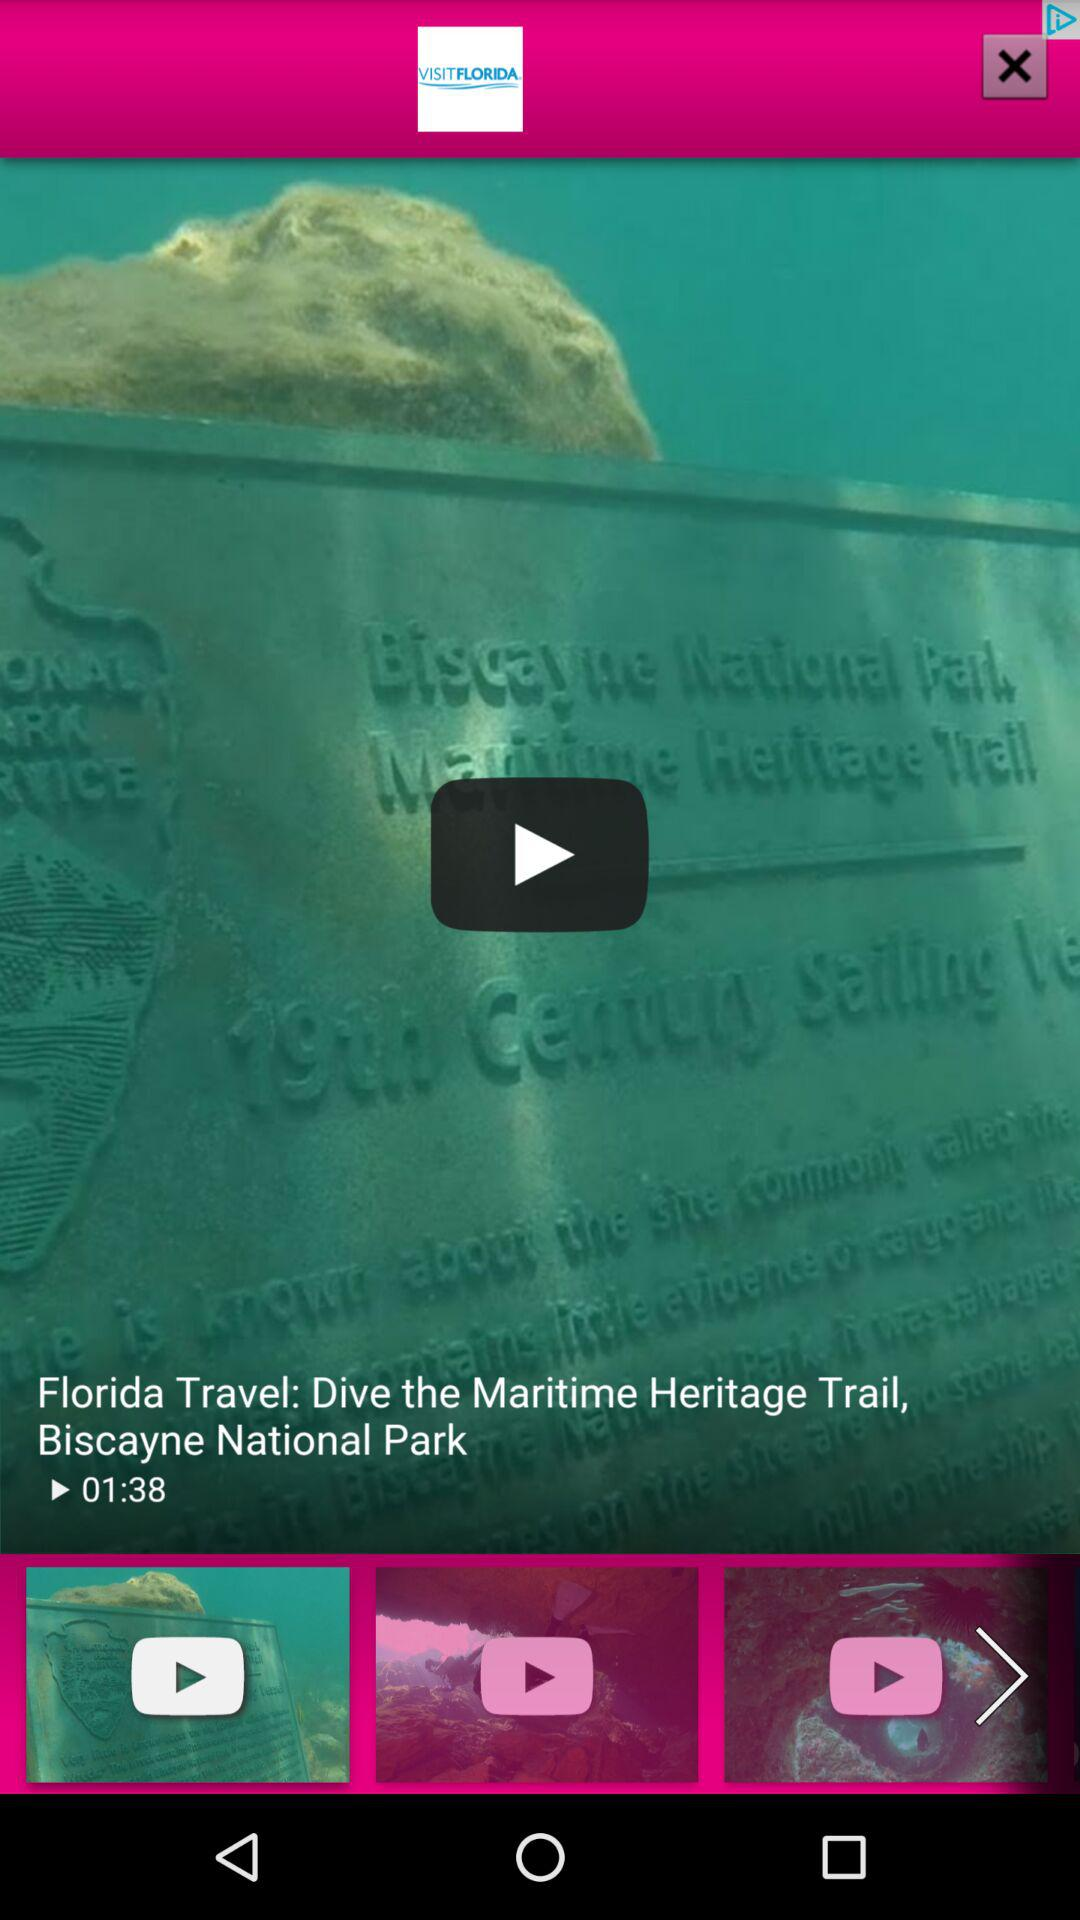What's the length of the video? The length of the video is 1 minute and 38 seconds. 